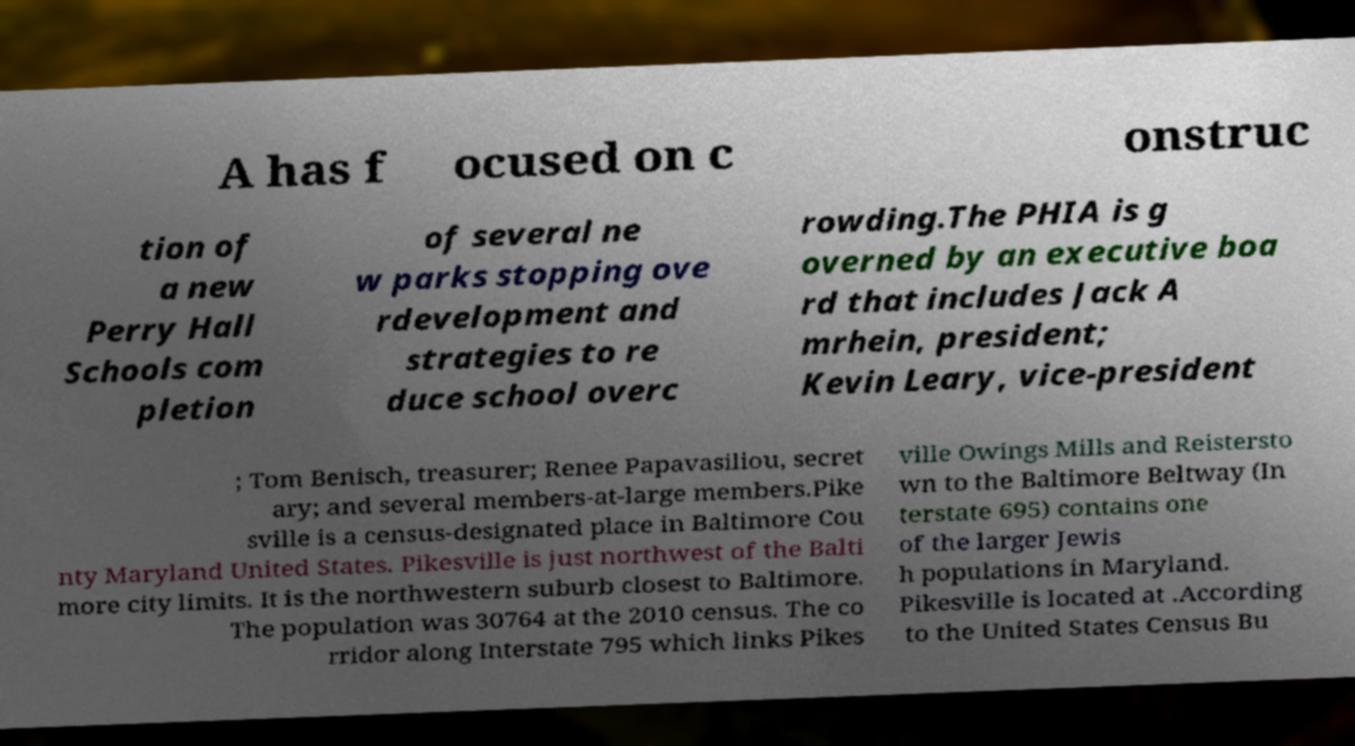Please read and relay the text visible in this image. What does it say? A has f ocused on c onstruc tion of a new Perry Hall Schools com pletion of several ne w parks stopping ove rdevelopment and strategies to re duce school overc rowding.The PHIA is g overned by an executive boa rd that includes Jack A mrhein, president; Kevin Leary, vice-president ; Tom Benisch, treasurer; Renee Papavasiliou, secret ary; and several members-at-large members.Pike sville is a census-designated place in Baltimore Cou nty Maryland United States. Pikesville is just northwest of the Balti more city limits. It is the northwestern suburb closest to Baltimore. The population was 30764 at the 2010 census. The co rridor along Interstate 795 which links Pikes ville Owings Mills and Reistersto wn to the Baltimore Beltway (In terstate 695) contains one of the larger Jewis h populations in Maryland. Pikesville is located at .According to the United States Census Bu 